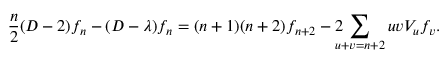<formula> <loc_0><loc_0><loc_500><loc_500>\frac { n } { 2 } ( D - 2 ) f _ { n } - ( D - \lambda ) f _ { n } = ( n + 1 ) ( n + 2 ) f _ { n + 2 } - 2 \, \sum _ { u + v = n + 2 } u v V _ { u } f _ { v } .</formula> 